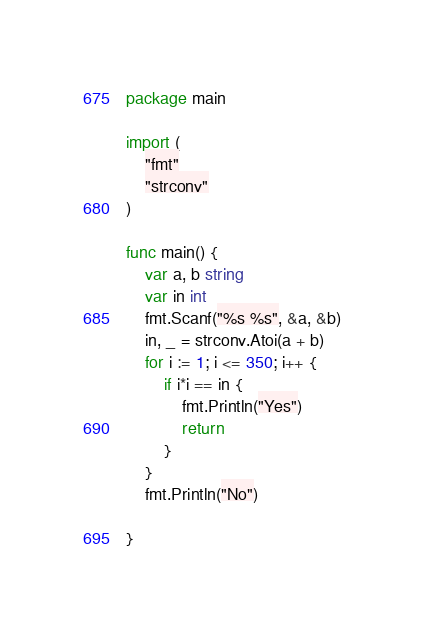Convert code to text. <code><loc_0><loc_0><loc_500><loc_500><_Go_>package main

import (
	"fmt"
	"strconv"
)

func main() {
	var a, b string
	var in int
	fmt.Scanf("%s %s", &a, &b)
	in, _ = strconv.Atoi(a + b)
	for i := 1; i <= 350; i++ {
		if i*i == in {
			fmt.Println("Yes")
			return
		}
	}
	fmt.Println("No")

}
</code> 